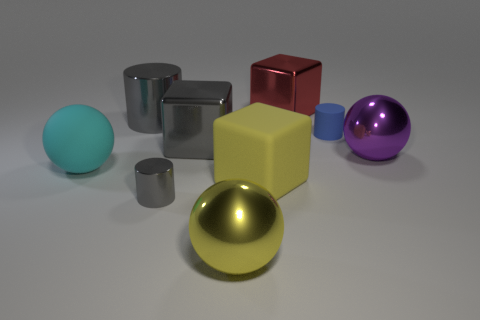Is there a gray object that has the same material as the small gray cylinder?
Keep it short and to the point. Yes. There is a metal thing that is the same color as the large rubber cube; what size is it?
Make the answer very short. Large. How many things are both in front of the tiny matte cylinder and to the right of the big red cube?
Ensure brevity in your answer.  1. There is a large block that is behind the big gray cylinder; what is it made of?
Provide a short and direct response. Metal. How many metallic cylinders are the same color as the tiny metal object?
Provide a succinct answer. 1. The yellow thing that is the same material as the large cyan ball is what size?
Provide a succinct answer. Large. How many things are either blue objects or gray metallic blocks?
Provide a succinct answer. 2. There is a tiny thing that is behind the gray cube; what color is it?
Your answer should be very brief. Blue. The gray metallic object that is the same shape as the yellow matte thing is what size?
Your answer should be compact. Large. What number of things are metal cylinders that are behind the gray cube or rubber objects right of the big cyan thing?
Provide a succinct answer. 3. 